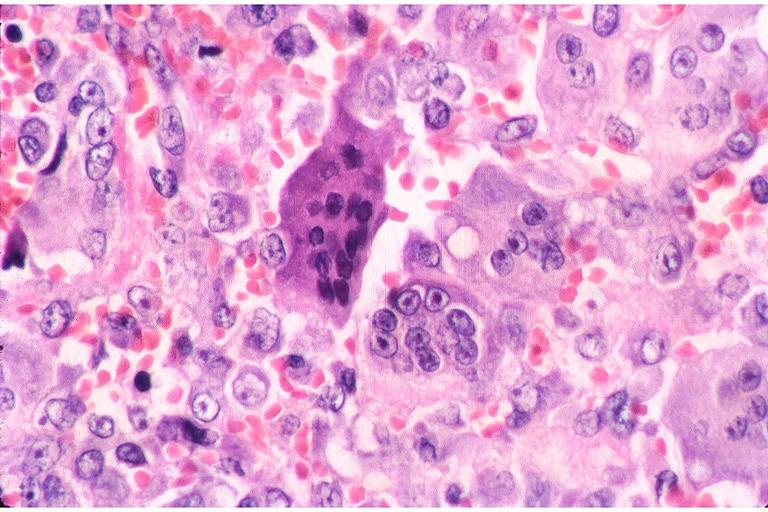does chronic myelogenous leukemia show central giant cell lesion?
Answer the question using a single word or phrase. No 